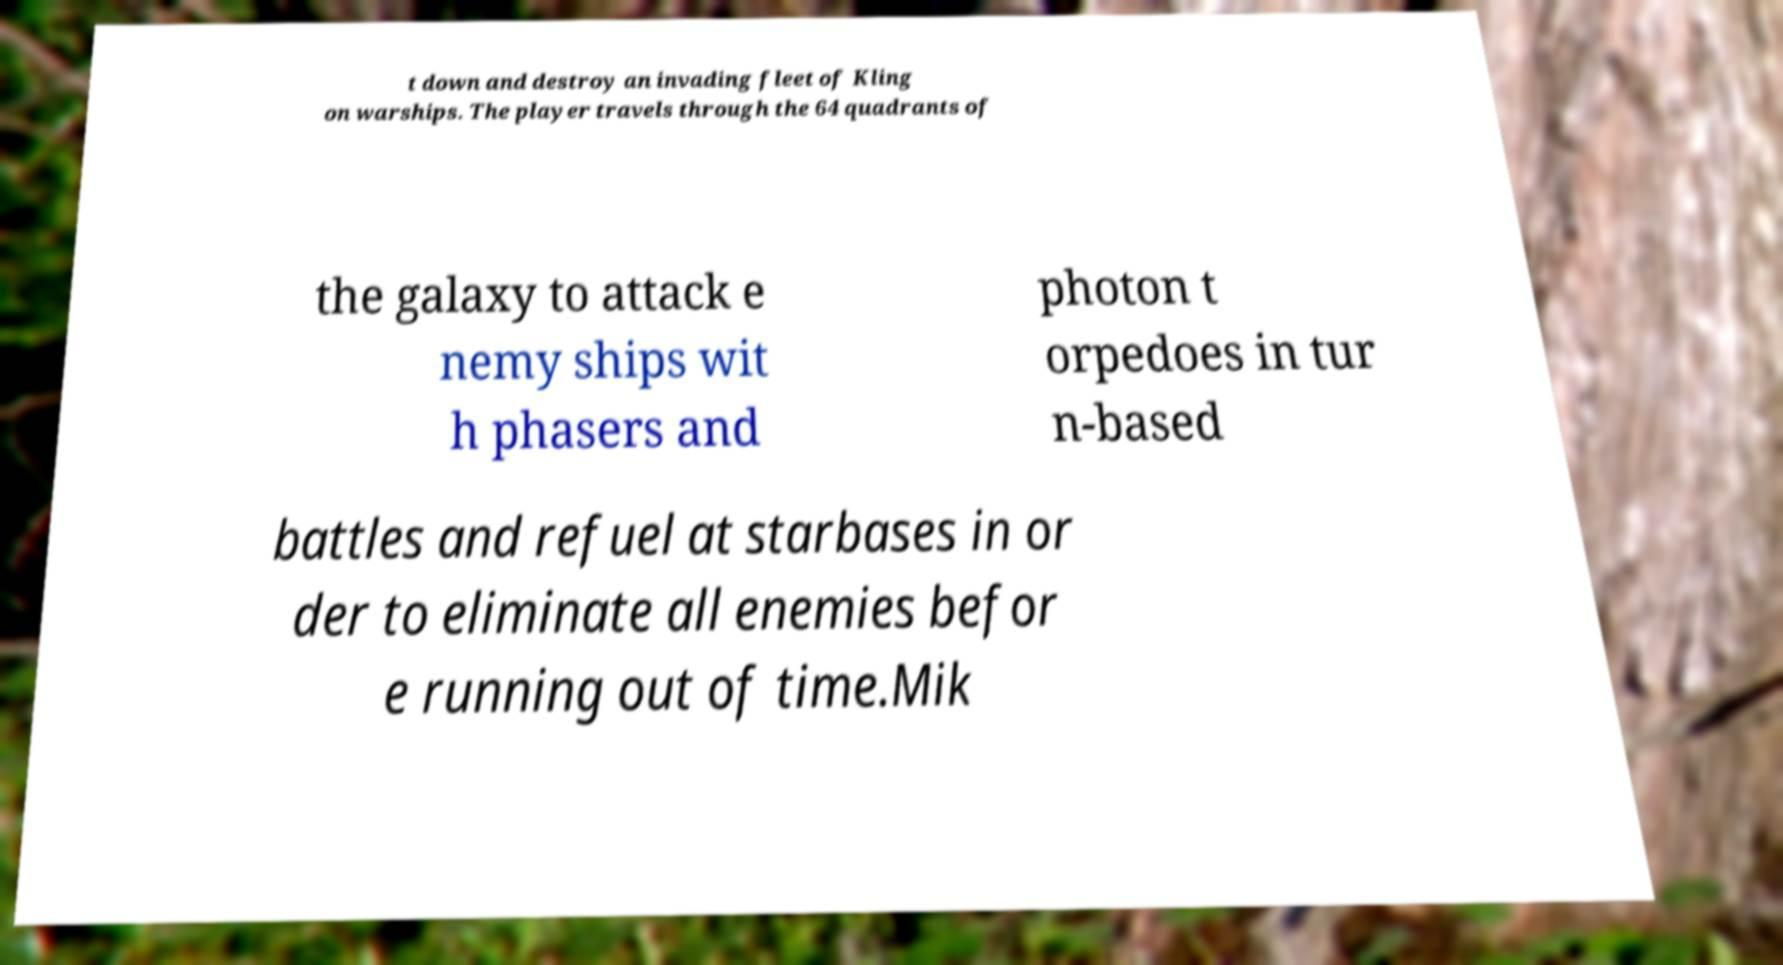Could you extract and type out the text from this image? t down and destroy an invading fleet of Kling on warships. The player travels through the 64 quadrants of the galaxy to attack e nemy ships wit h phasers and photon t orpedoes in tur n-based battles and refuel at starbases in or der to eliminate all enemies befor e running out of time.Mik 